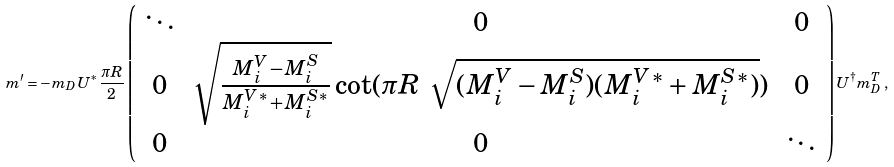<formula> <loc_0><loc_0><loc_500><loc_500>m ^ { \prime } = - m _ { D } U ^ { * } \frac { \pi R } { 2 } \left ( \begin{array} { c c c } \ddots & 0 & 0 \\ 0 & \sqrt { \frac { M ^ { V } _ { i } - M ^ { S } _ { i } } { M ^ { V * } _ { i } + M ^ { S * } _ { i } } } \cot ( \pi R \ \sqrt { ( M ^ { V } _ { i } - M ^ { S } _ { i } ) ( M ^ { V * } _ { i } + M ^ { S * } _ { i } ) } ) & 0 \\ 0 & 0 & \ddots \end{array} \right ) U ^ { \dagger } m _ { D } ^ { T } \, ,</formula> 